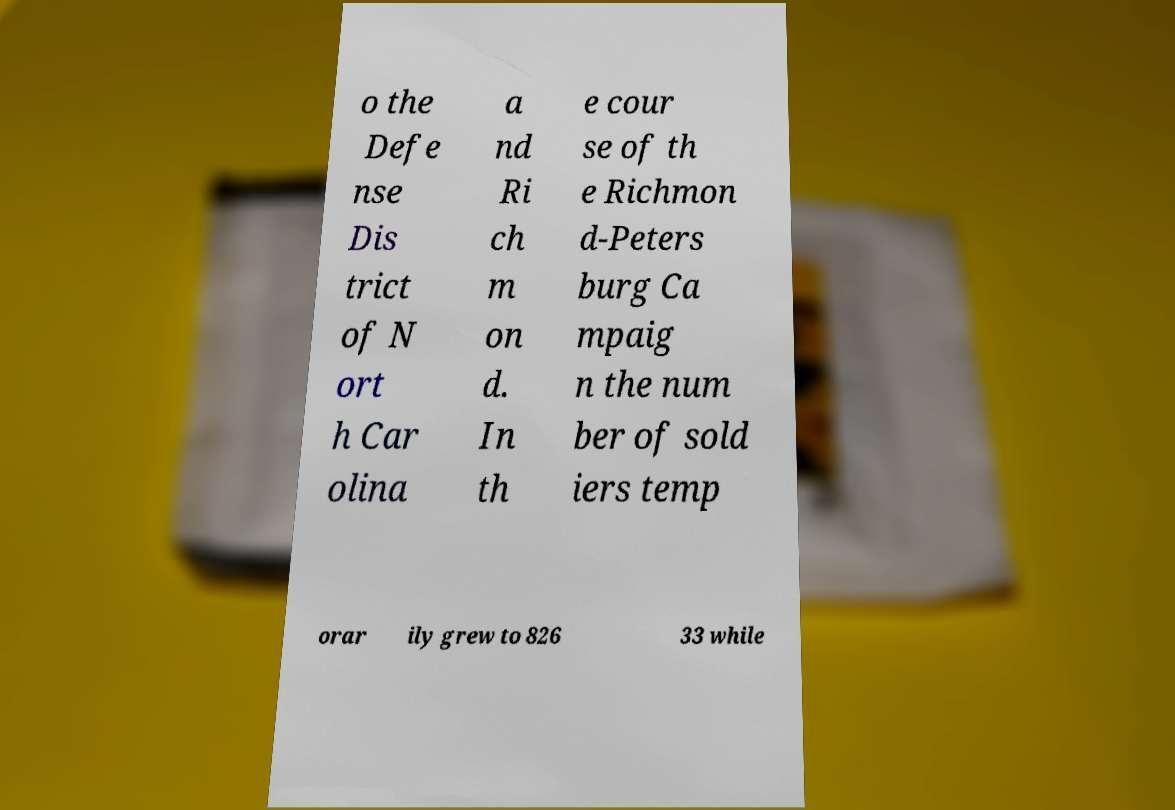Could you assist in decoding the text presented in this image and type it out clearly? o the Defe nse Dis trict of N ort h Car olina a nd Ri ch m on d. In th e cour se of th e Richmon d-Peters burg Ca mpaig n the num ber of sold iers temp orar ily grew to 826 33 while 